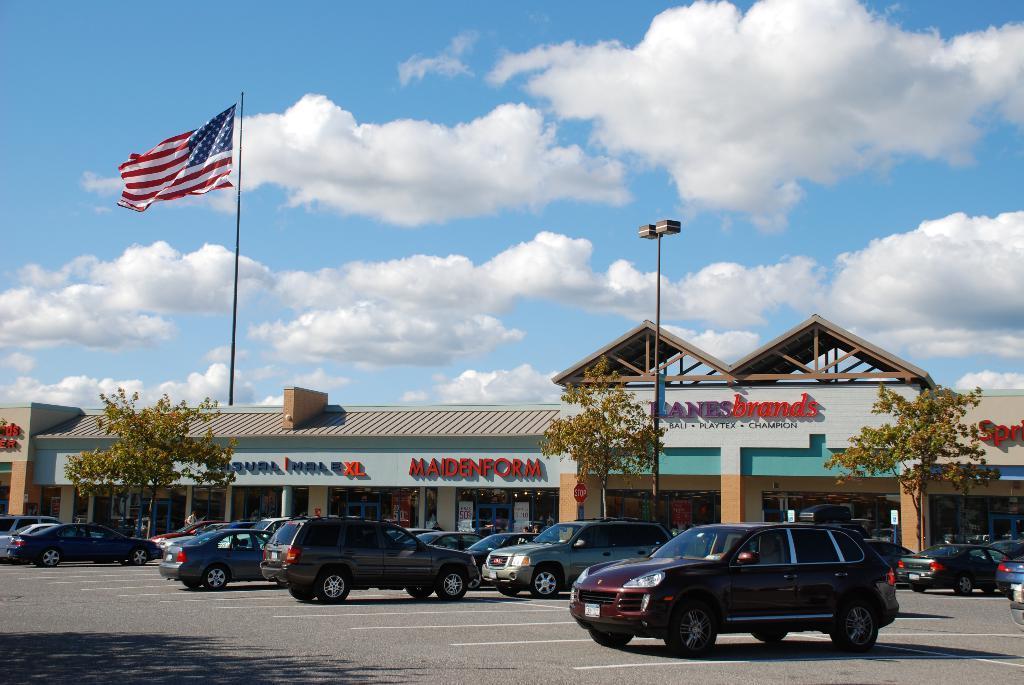Please provide a concise description of this image. In the foreground of the image we can see group of vehicles parked on the ground. In the center of the image we can see a building with sign boards and some text, a group of trees and poles. In the background, we can see a flag on a pole and the cloudy sky. 